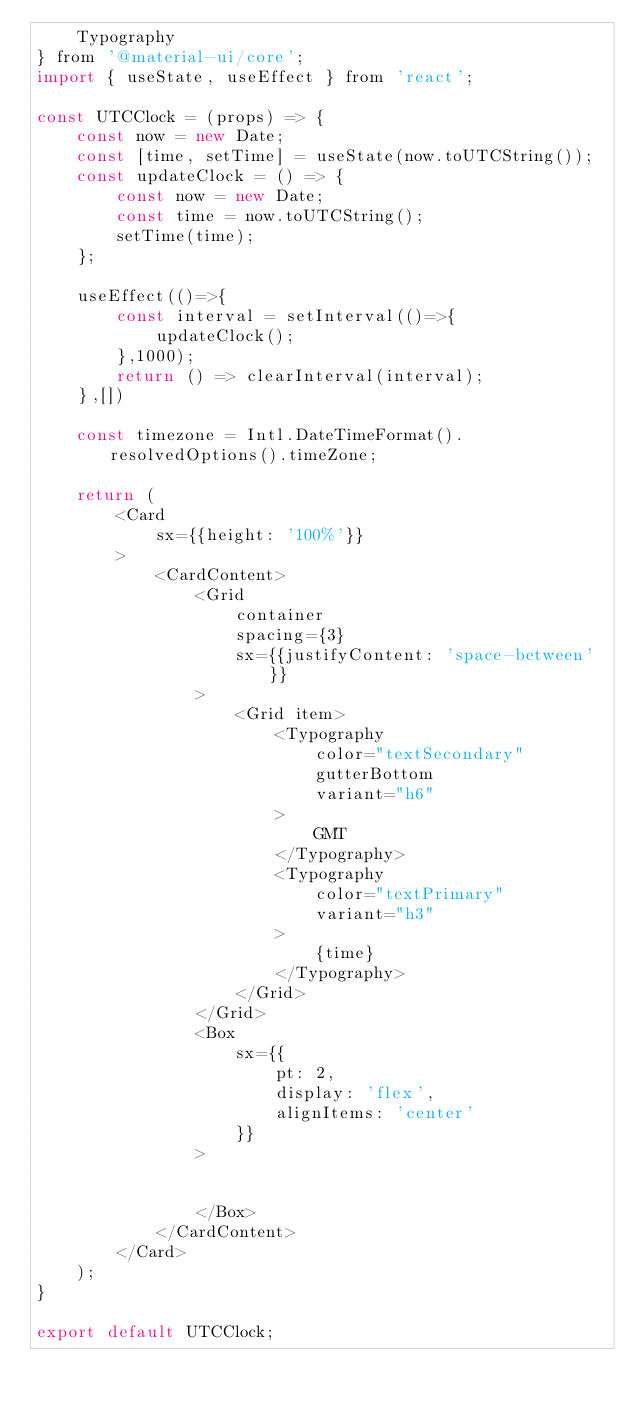<code> <loc_0><loc_0><loc_500><loc_500><_JavaScript_>    Typography
} from '@material-ui/core';
import { useState, useEffect } from 'react';

const UTCClock = (props) => {
    const now = new Date;
    const [time, setTime] = useState(now.toUTCString());
    const updateClock = () => {
        const now = new Date;
        const time = now.toUTCString();
        setTime(time);
    };

    useEffect(()=>{
        const interval = setInterval(()=>{
            updateClock();
        },1000);
        return () => clearInterval(interval);
    },[])

    const timezone = Intl.DateTimeFormat().resolvedOptions().timeZone;

    return (
        <Card
            sx={{height: '100%'}}
        >
            <CardContent>
                <Grid
                    container
                    spacing={3}
                    sx={{justifyContent: 'space-between'}}
                >
                    <Grid item>
                        <Typography
                            color="textSecondary"
                            gutterBottom
                            variant="h6"
                        >
                            GMT
                        </Typography>
                        <Typography
                            color="textPrimary"
                            variant="h3"
                        >
                            {time}
                        </Typography>
                    </Grid>
                </Grid>
                <Box
                    sx={{
                        pt: 2,
                        display: 'flex',
                        alignItems: 'center'
                    }}
                >


                </Box>
            </CardContent>
        </Card>
    );
}

export default UTCClock;
</code> 